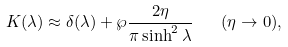<formula> <loc_0><loc_0><loc_500><loc_500>K ( \lambda ) \approx \delta ( \lambda ) + \wp \frac { 2 \eta } { \pi \sinh ^ { 2 } \lambda } \quad ( \eta \rightarrow 0 ) ,</formula> 